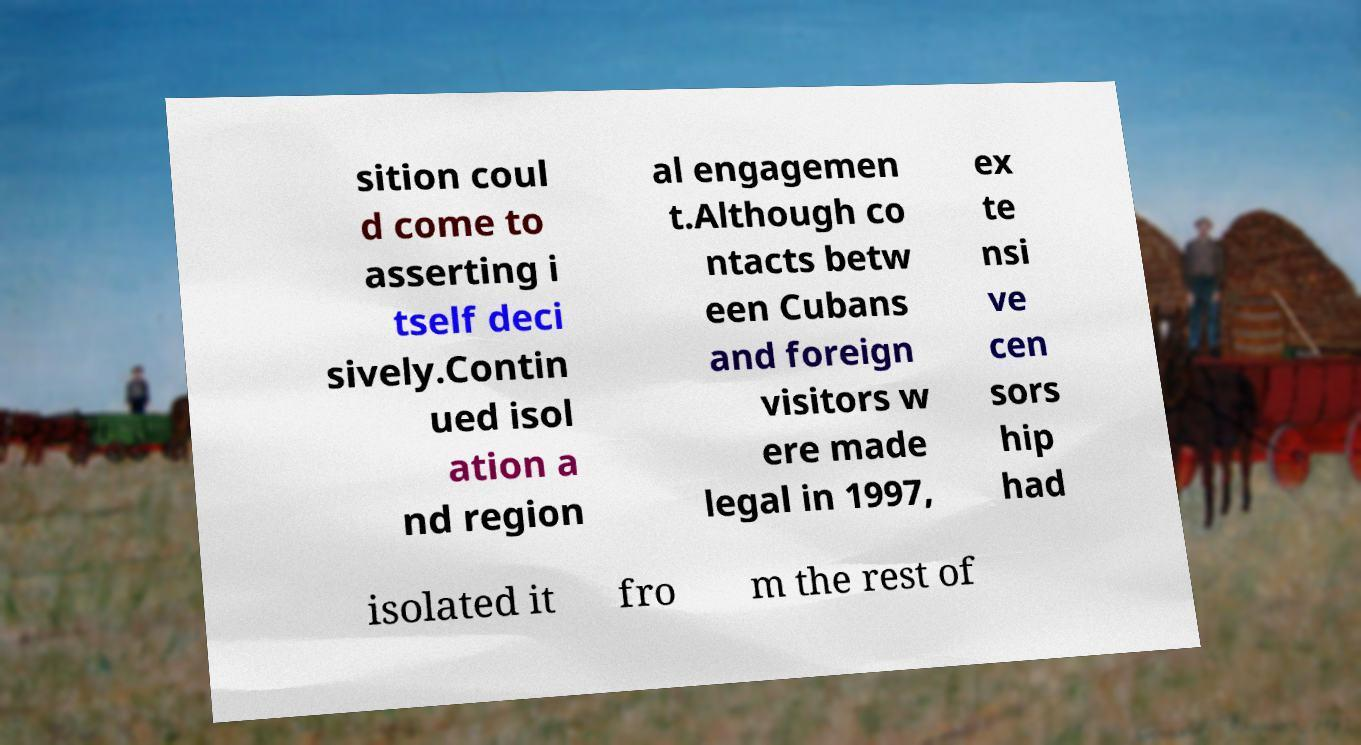There's text embedded in this image that I need extracted. Can you transcribe it verbatim? sition coul d come to asserting i tself deci sively.Contin ued isol ation a nd region al engagemen t.Although co ntacts betw een Cubans and foreign visitors w ere made legal in 1997, ex te nsi ve cen sors hip had isolated it fro m the rest of 